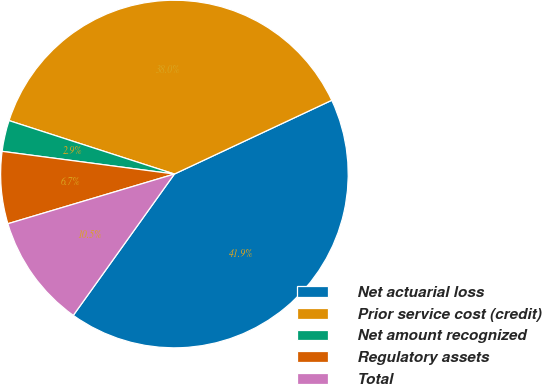<chart> <loc_0><loc_0><loc_500><loc_500><pie_chart><fcel>Net actuarial loss<fcel>Prior service cost (credit)<fcel>Net amount recognized<fcel>Regulatory assets<fcel>Total<nl><fcel>41.86%<fcel>38.05%<fcel>2.89%<fcel>6.7%<fcel>10.5%<nl></chart> 